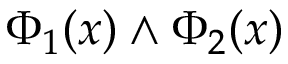<formula> <loc_0><loc_0><loc_500><loc_500>\Phi _ { 1 } ( x ) \land \Phi _ { 2 } ( x )</formula> 